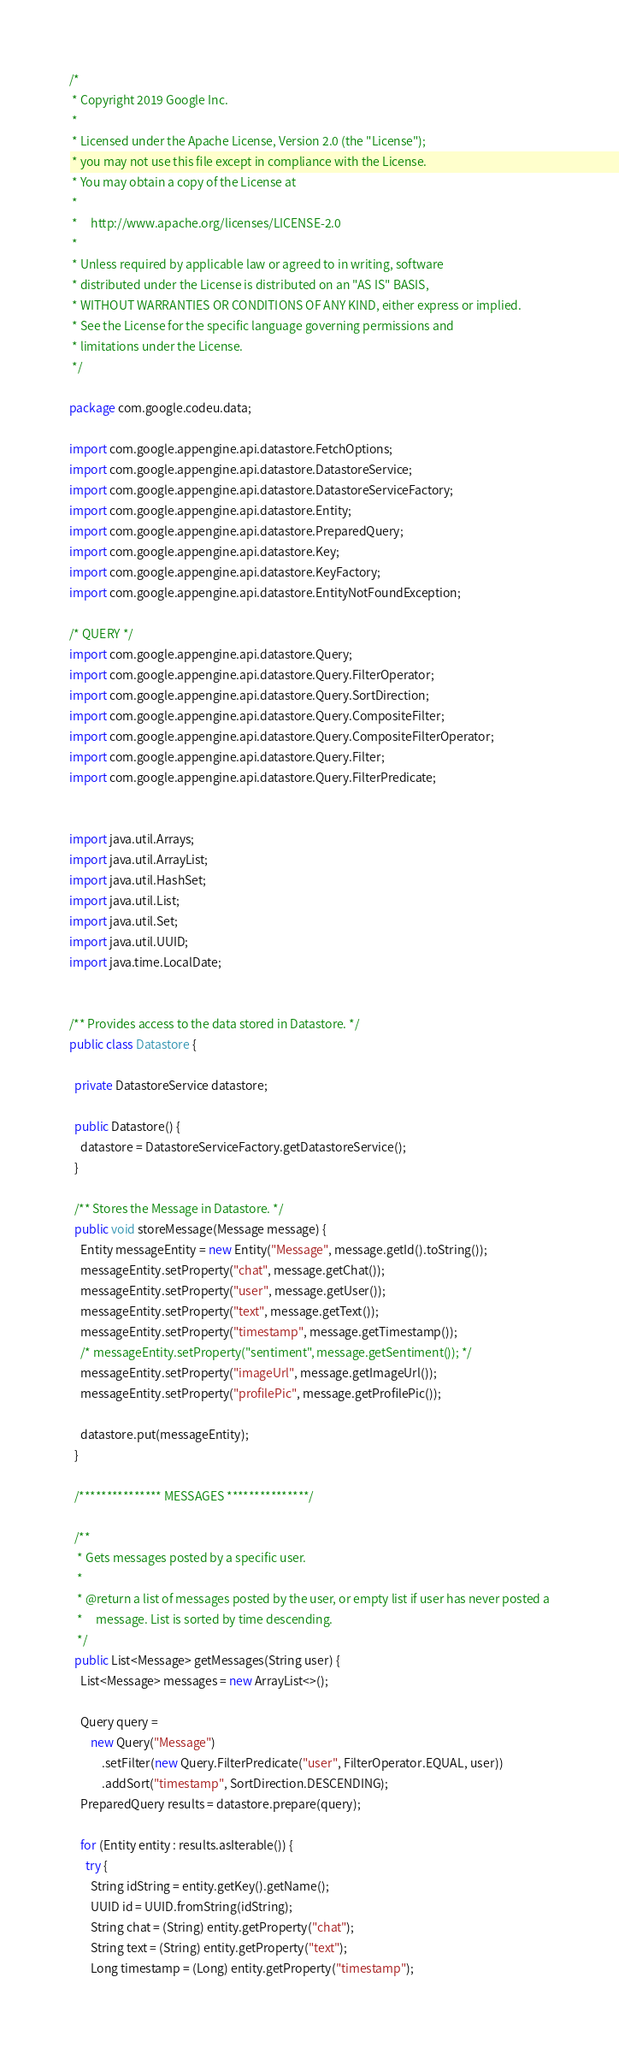<code> <loc_0><loc_0><loc_500><loc_500><_Java_>/*
 * Copyright 2019 Google Inc.
 *
 * Licensed under the Apache License, Version 2.0 (the "License");
 * you may not use this file except in compliance with the License.
 * You may obtain a copy of the License at
 *
 *     http://www.apache.org/licenses/LICENSE-2.0
 *
 * Unless required by applicable law or agreed to in writing, software
 * distributed under the License is distributed on an "AS IS" BASIS,
 * WITHOUT WARRANTIES OR CONDITIONS OF ANY KIND, either express or implied.
 * See the License for the specific language governing permissions and
 * limitations under the License.
 */

package com.google.codeu.data;

import com.google.appengine.api.datastore.FetchOptions;
import com.google.appengine.api.datastore.DatastoreService;
import com.google.appengine.api.datastore.DatastoreServiceFactory;
import com.google.appengine.api.datastore.Entity;
import com.google.appengine.api.datastore.PreparedQuery;
import com.google.appengine.api.datastore.Key;
import com.google.appengine.api.datastore.KeyFactory;
import com.google.appengine.api.datastore.EntityNotFoundException;

/* QUERY */
import com.google.appengine.api.datastore.Query;
import com.google.appengine.api.datastore.Query.FilterOperator;
import com.google.appengine.api.datastore.Query.SortDirection;
import com.google.appengine.api.datastore.Query.CompositeFilter;
import com.google.appengine.api.datastore.Query.CompositeFilterOperator;
import com.google.appengine.api.datastore.Query.Filter;
import com.google.appengine.api.datastore.Query.FilterPredicate;


import java.util.Arrays;
import java.util.ArrayList;
import java.util.HashSet;
import java.util.List;
import java.util.Set;
import java.util.UUID;
import java.time.LocalDate;


/** Provides access to the data stored in Datastore. */
public class Datastore {

  private DatastoreService datastore;

  public Datastore() {
    datastore = DatastoreServiceFactory.getDatastoreService();
  }

  /** Stores the Message in Datastore. */
  public void storeMessage(Message message) {
    Entity messageEntity = new Entity("Message", message.getId().toString());
    messageEntity.setProperty("chat", message.getChat());
    messageEntity.setProperty("user", message.getUser());
    messageEntity.setProperty("text", message.getText());
    messageEntity.setProperty("timestamp", message.getTimestamp());
    /* messageEntity.setProperty("sentiment", message.getSentiment()); */
    messageEntity.setProperty("imageUrl", message.getImageUrl());
    messageEntity.setProperty("profilePic", message.getProfilePic());

    datastore.put(messageEntity);
  }

  /*************** MESSAGES ***************/

  /**
   * Gets messages posted by a specific user.
   *
   * @return a list of messages posted by the user, or empty list if user has never posted a
   *     message. List is sorted by time descending.
   */
  public List<Message> getMessages(String user) {
    List<Message> messages = new ArrayList<>();

    Query query =
        new Query("Message")
            .setFilter(new Query.FilterPredicate("user", FilterOperator.EQUAL, user))
            .addSort("timestamp", SortDirection.DESCENDING);
    PreparedQuery results = datastore.prepare(query);

    for (Entity entity : results.asIterable()) {
      try {
        String idString = entity.getKey().getName();
        UUID id = UUID.fromString(idString);
        String chat = (String) entity.getProperty("chat");
        String text = (String) entity.getProperty("text");
        Long timestamp = (Long) entity.getProperty("timestamp");</code> 